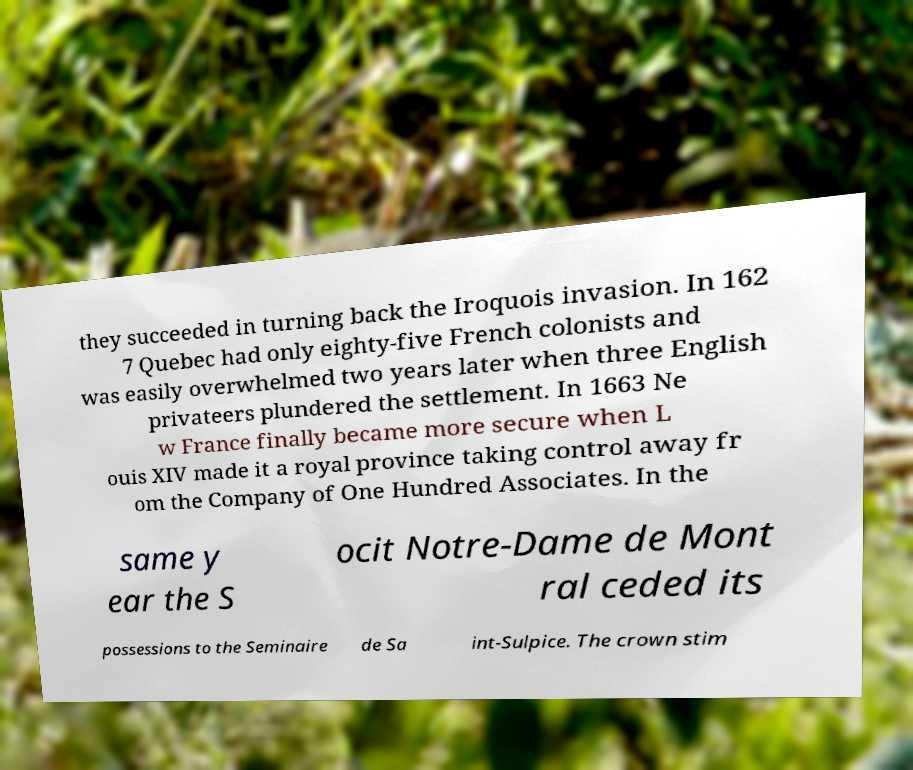Can you accurately transcribe the text from the provided image for me? they succeeded in turning back the Iroquois invasion. In 162 7 Quebec had only eighty-five French colonists and was easily overwhelmed two years later when three English privateers plundered the settlement. In 1663 Ne w France finally became more secure when L ouis XIV made it a royal province taking control away fr om the Company of One Hundred Associates. In the same y ear the S ocit Notre-Dame de Mont ral ceded its possessions to the Seminaire de Sa int-Sulpice. The crown stim 